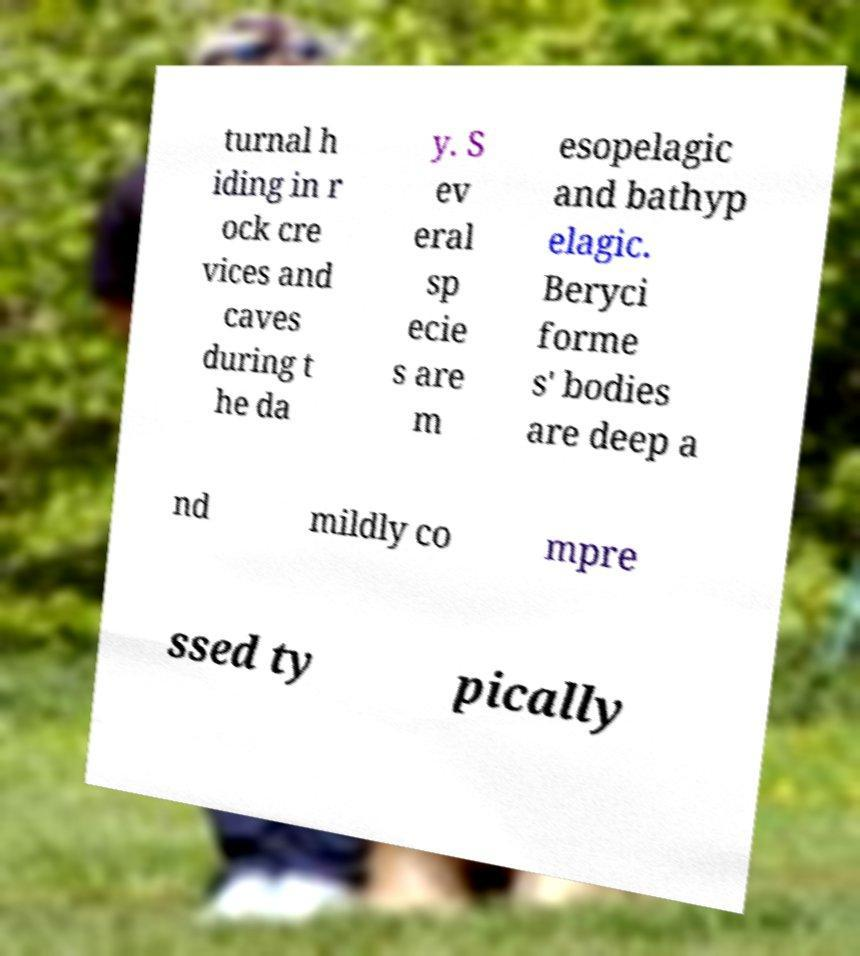I need the written content from this picture converted into text. Can you do that? turnal h iding in r ock cre vices and caves during t he da y. S ev eral sp ecie s are m esopelagic and bathyp elagic. Beryci forme s' bodies are deep a nd mildly co mpre ssed ty pically 